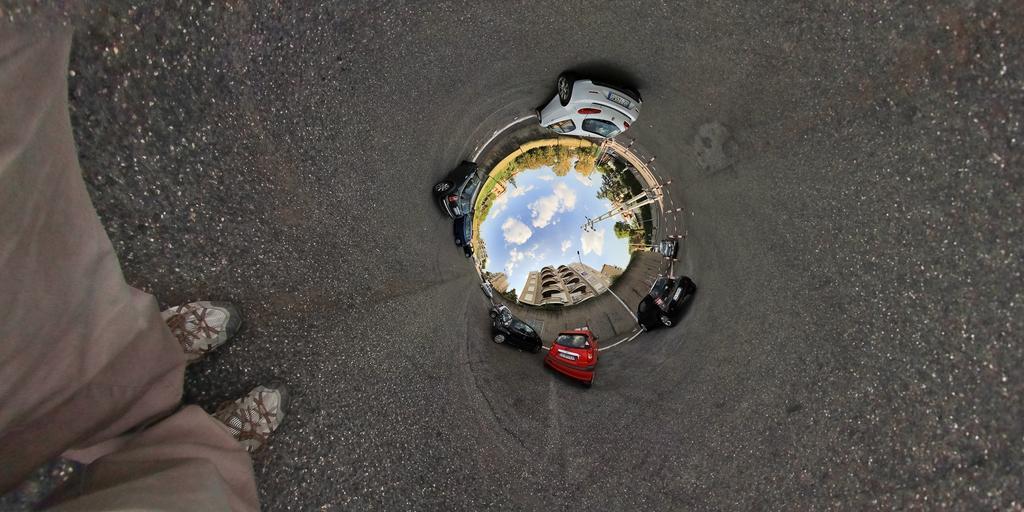In one or two sentences, can you explain what this image depicts? In this image I can see the road which is black in color, a person's legs wearing pant and shoe is standing on the road. I can see few cars which are red, black and white in color on the road. I can see few trees, few buildings and the sky in the background. 